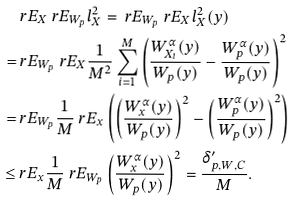<formula> <loc_0><loc_0><loc_500><loc_500>& \ r E _ { X } \ r E _ { W _ { p } } l _ { X } ^ { 2 } = \ r E _ { W _ { p } } \ r E _ { X } l _ { X } ^ { 2 } ( y ) \\ = & \ r E _ { W _ { p } } \ r E _ { X } \frac { 1 } { M ^ { 2 } } \sum _ { i = 1 } ^ { M } \left ( \frac { W _ { X _ { i } } ^ { \alpha } ( y ) } { W _ { p } ( y ) } - \frac { W _ { p } ^ { \alpha } ( y ) } { W _ { p } ( y ) } \right ) ^ { 2 } \\ = & \ r E _ { W _ { p } } \frac { 1 } { M } \ r E _ { x } \left ( \left ( \frac { W _ { x } ^ { \alpha } ( y ) } { W _ { p } ( y ) } \right ) ^ { 2 } - \left ( \frac { W _ { p } ^ { \alpha } ( y ) } { W _ { p } ( y ) } \right ) ^ { 2 } \right ) \\ \leq & \ r E _ { x } \frac { 1 } { M } \ r E _ { W _ { p } } \left ( \frac { W _ { x } ^ { \alpha } ( y ) } { W _ { p } ( y ) } \right ) ^ { 2 } = \frac { \delta _ { p , W , C } ^ { \prime } } { M } .</formula> 